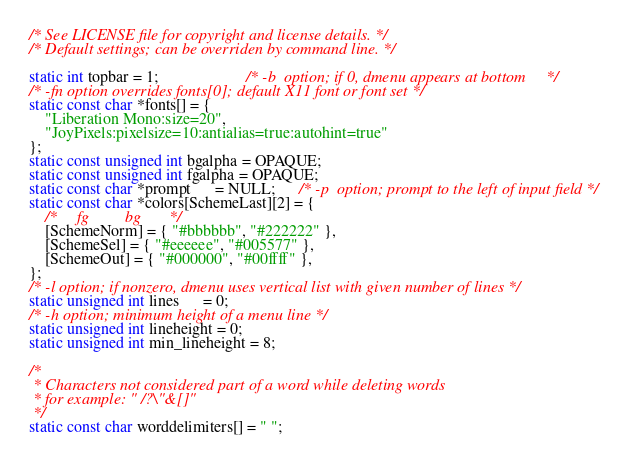Convert code to text. <code><loc_0><loc_0><loc_500><loc_500><_C_>/* See LICENSE file for copyright and license details. */
/* Default settings; can be overriden by command line. */

static int topbar = 1;                      /* -b  option; if 0, dmenu appears at bottom     */
/* -fn option overrides fonts[0]; default X11 font or font set */
static const char *fonts[] = { 
	"Liberation Mono:size=20",
	"JoyPixels:pixelsize=10:antialias=true:autohint=true" 
};
static const unsigned int bgalpha = OPAQUE;
static const unsigned int fgalpha = OPAQUE;
static const char *prompt      = NULL;      /* -p  option; prompt to the left of input field */
static const char *colors[SchemeLast][2] = {
	/*     fg         bg       */
	[SchemeNorm] = { "#bbbbbb", "#222222" },
	[SchemeSel] = { "#eeeeee", "#005577" },
	[SchemeOut] = { "#000000", "#00ffff" },
};
/* -l option; if nonzero, dmenu uses vertical list with given number of lines */
static unsigned int lines      = 0;
/* -h option; minimum height of a menu line */
static unsigned int lineheight = 0;
static unsigned int min_lineheight = 8;

/*
 * Characters not considered part of a word while deleting words
 * for example: " /?\"&[]"
 */
static const char worddelimiters[] = " ";
</code> 